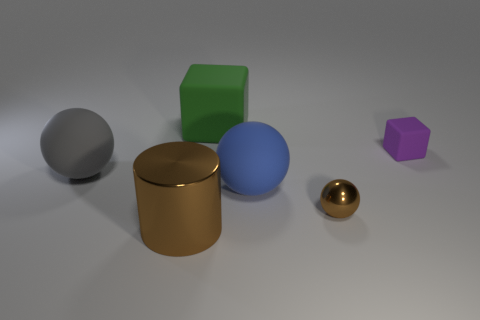Is the big metallic thing the same color as the tiny metallic ball?
Keep it short and to the point. Yes. Do the tiny thing that is in front of the gray matte object and the purple object behind the metallic cylinder have the same shape?
Give a very brief answer. No. The other object that is the same color as the small metal object is what shape?
Your response must be concise. Cylinder. Are there any tiny purple objects made of the same material as the gray object?
Ensure brevity in your answer.  Yes. How many metallic things are either gray things or yellow cubes?
Your response must be concise. 0. There is a large rubber thing behind the rubber cube that is to the right of the metallic sphere; what is its shape?
Provide a short and direct response. Cube. Are there fewer tiny brown metal balls that are on the left side of the large blue matte thing than small brown balls?
Provide a succinct answer. Yes. What shape is the purple object?
Your answer should be very brief. Cube. There is a matte sphere in front of the large gray matte thing; what size is it?
Keep it short and to the point. Large. What is the color of the sphere that is the same size as the purple object?
Provide a short and direct response. Brown. 